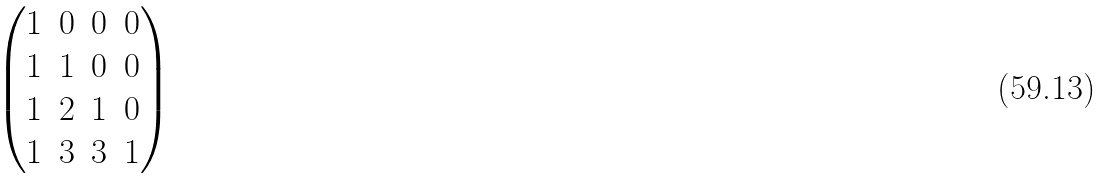<formula> <loc_0><loc_0><loc_500><loc_500>\begin{pmatrix} 1 & 0 & 0 & 0 \\ 1 & 1 & 0 & 0 \\ 1 & 2 & 1 & 0 \\ 1 & 3 & 3 & 1 \end{pmatrix}</formula> 